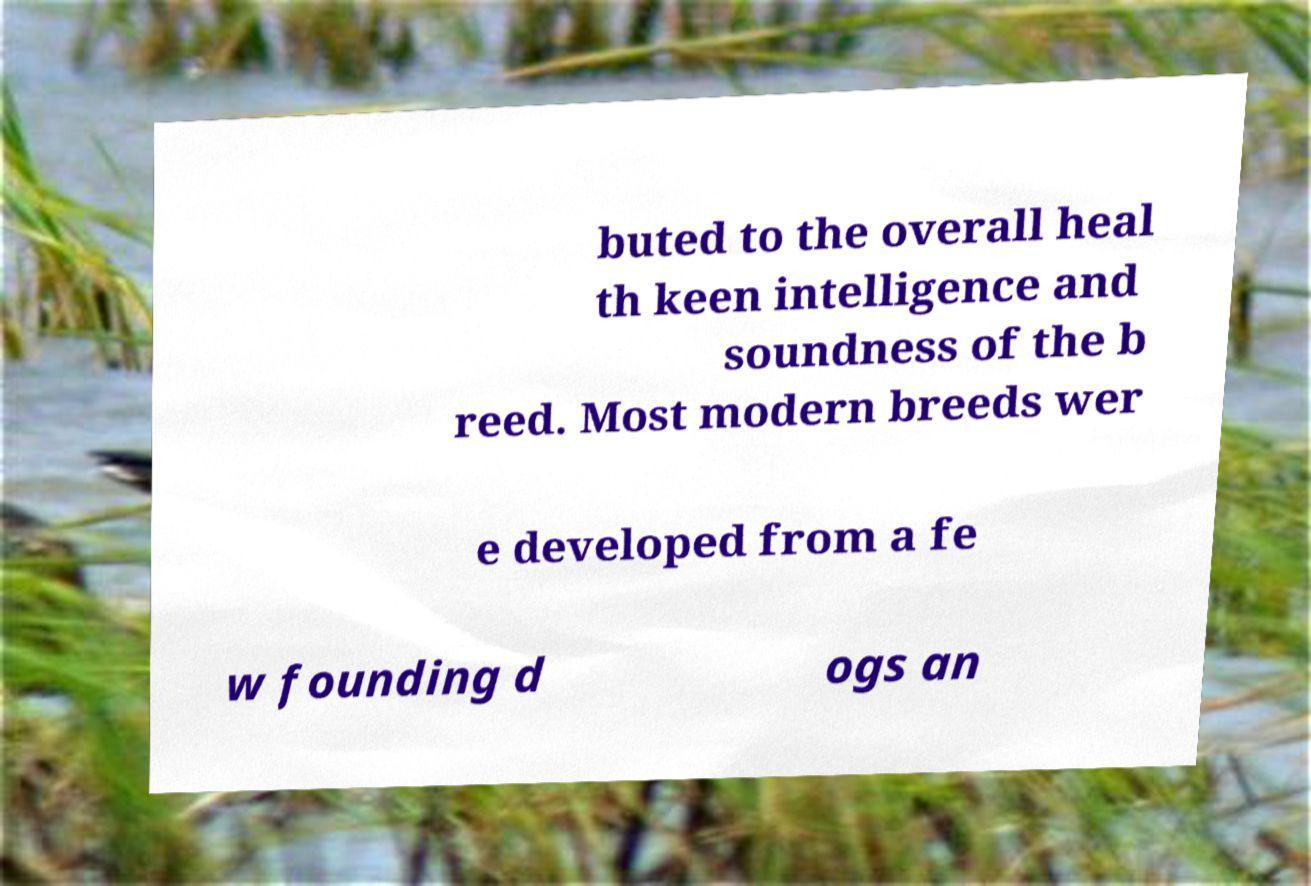For documentation purposes, I need the text within this image transcribed. Could you provide that? buted to the overall heal th keen intelligence and soundness of the b reed. Most modern breeds wer e developed from a fe w founding d ogs an 